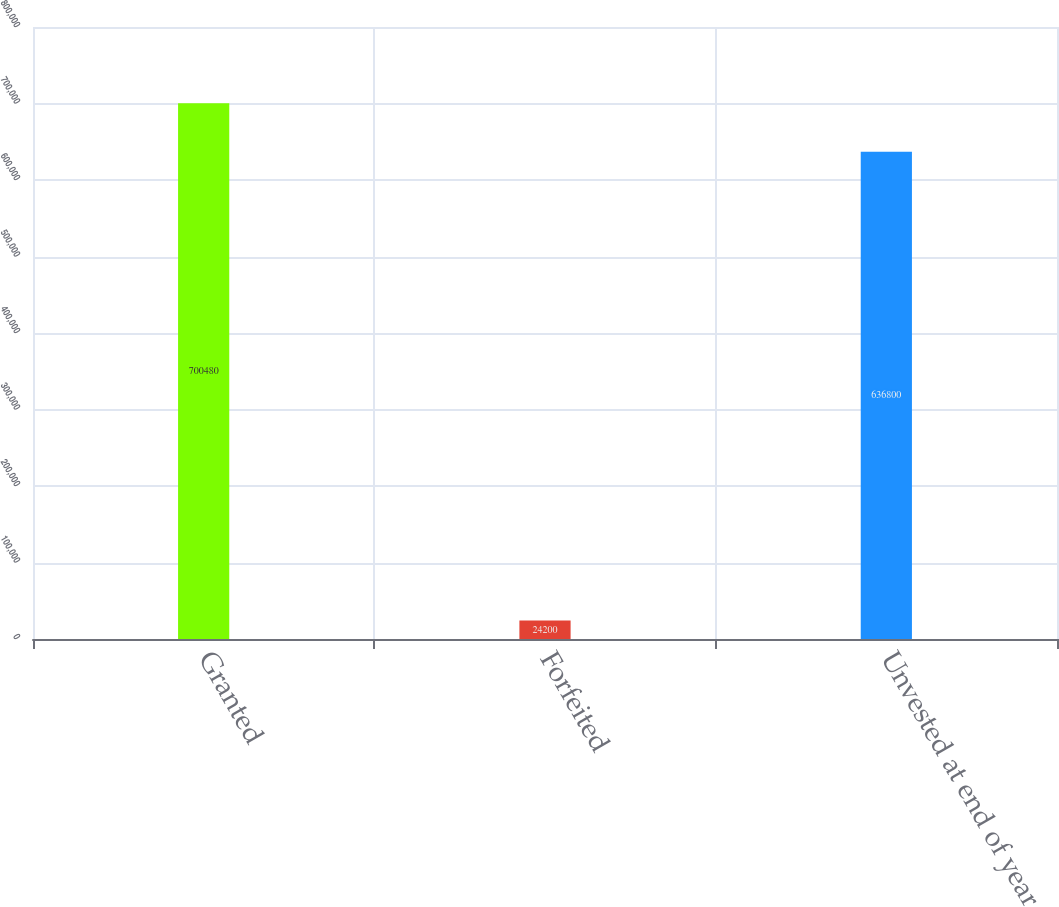<chart> <loc_0><loc_0><loc_500><loc_500><bar_chart><fcel>Granted<fcel>Forfeited<fcel>Unvested at end of year<nl><fcel>700480<fcel>24200<fcel>636800<nl></chart> 